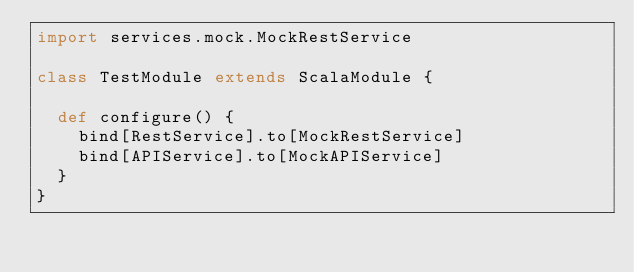<code> <loc_0><loc_0><loc_500><loc_500><_Scala_>import services.mock.MockRestService

class TestModule extends ScalaModule {

  def configure() {
    bind[RestService].to[MockRestService]
    bind[APIService].to[MockAPIService]
  }
}</code> 